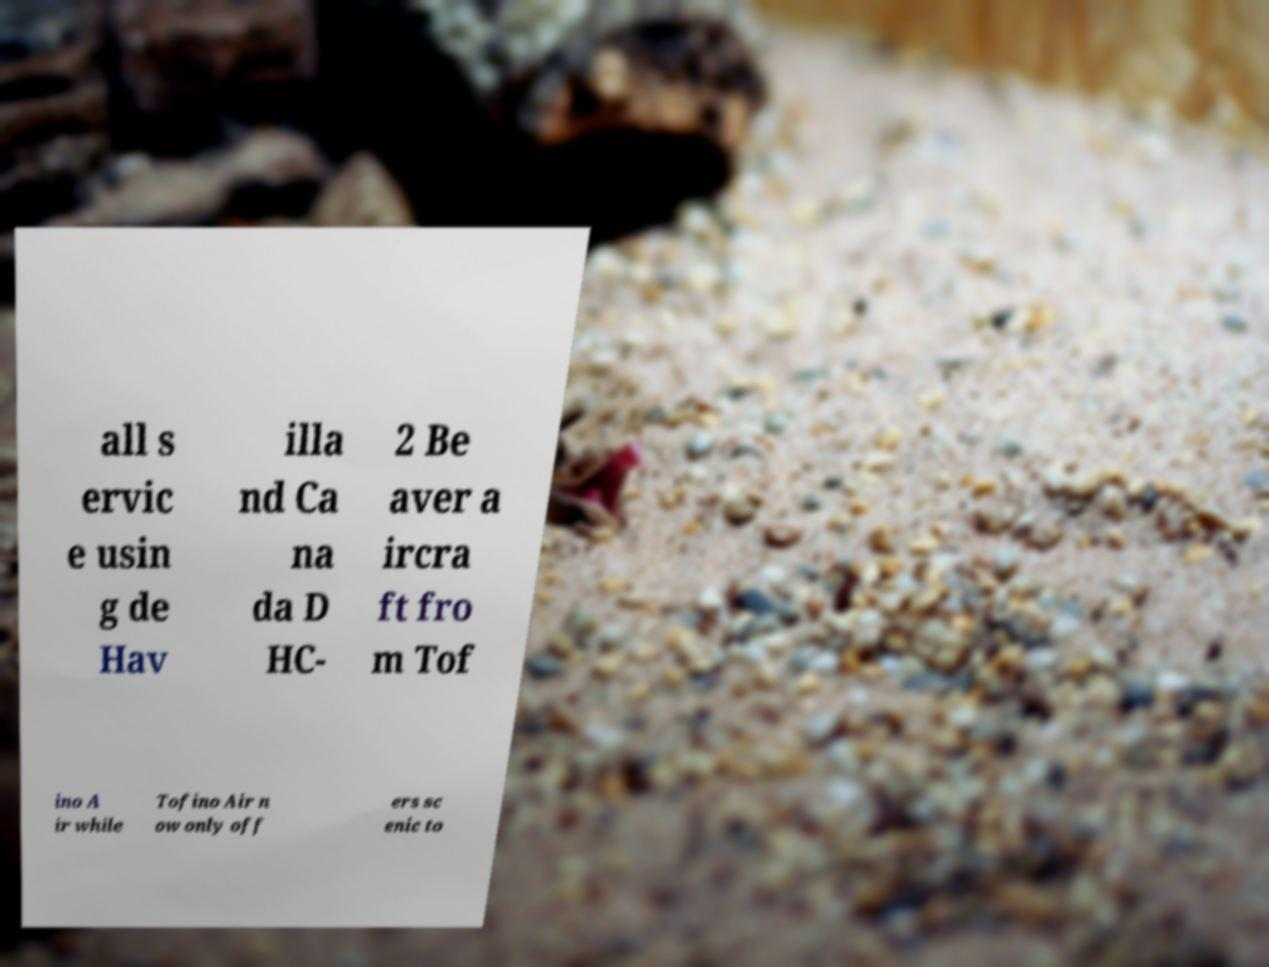There's text embedded in this image that I need extracted. Can you transcribe it verbatim? all s ervic e usin g de Hav illa nd Ca na da D HC- 2 Be aver a ircra ft fro m Tof ino A ir while Tofino Air n ow only off ers sc enic to 